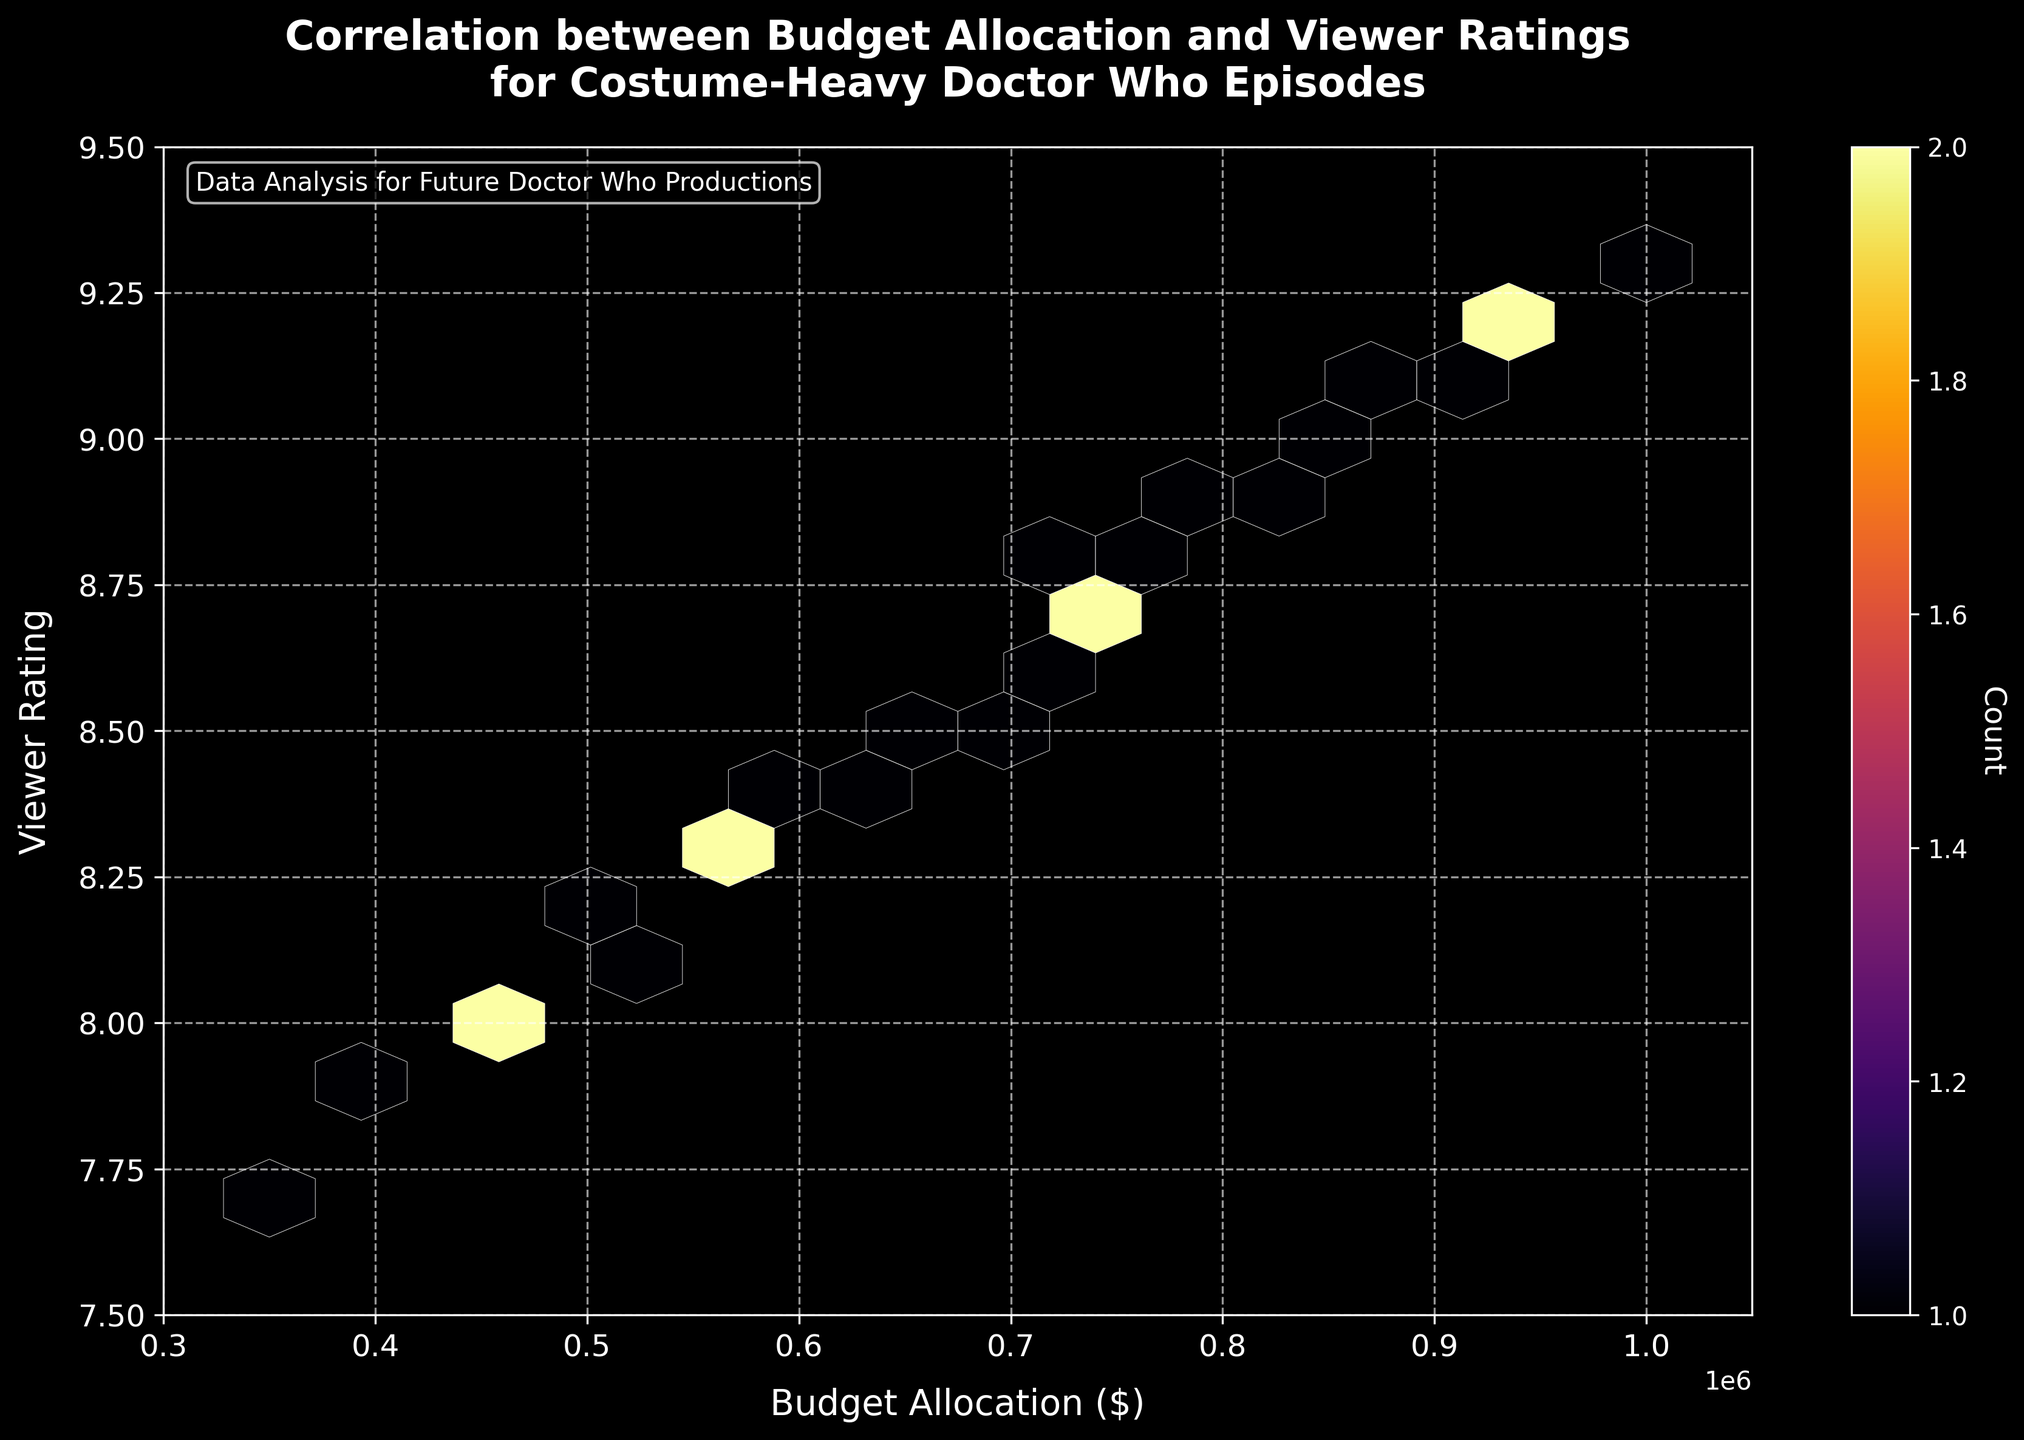How many bins are shown in the hexbin plot? The hexbin plot uses a grid of hexagons, and the number of bins corresponds to the number of hexagons shown. In this plot, the grid size is set to 15, which means there will be approximately 15 bins along each axis, resulting in a more granular hexbin plot.
Answer: Approximately 225 bins What's the title of the hexbin plot? The title is prominently displayed at the top of the plot. It reads: "Correlation between Budget Allocation and Viewer Ratings for Costume-Heavy Doctor Who Episodes."
Answer: Correlation between Budget Allocation and Viewer Ratings for Costume-Heavy Doctor Who Episodes What are the axis labels in the plot? The labels for the axes can be found near the x-axis and y-axis. The x-axis is labeled "Budget Allocation ($)," and the y-axis is labeled "Viewer Rating."
Answer: Budget Allocation ($) on x-axis and Viewer Rating on y-axis What is the range of budget allocations shown in the plot? Looking at the x-axis, the range of budget allocations spans from $300,000 to $1,050,000, as indicated by the limits set on the axis.
Answer: $300,000 to $1,050,000 What is the highest viewer rating in the dataset, and what budget allocation does it correspond to? The highest viewer rating can be found on the y-axis, peaking at approximately 9.3. The corresponding budget allocation for this highest rating, as per the data provided, is $1,000,000.
Answer: 9.3 with $1,000,000 budget How many data points fall in the bin with the highest count? The color intensity in the hexbin plot indicates the number of data points within each bin. The color bar on the right helps identify the bin with the highest count. This bin corresponds to the darkest color, which indicates a count of 2.
Answer: 2 data points Which budget allocation range has the densest concentration of viewer ratings based on the hexbin plot? By examining the hexbin plot, the densest concentration of viewer ratings is where the hexagons are most tightly clustered and exhibit darker colors. The range of budget allocation with the densest concentration falls between $700,000 and $800,000.
Answer: $700,000 to $800,000 Is there a visible correlation between budget allocation and viewer ratings based on the hexbin plot? The hexbin plot shows a trend where higher budget allocations seem to generally correspond to higher viewer ratings. This positive correlation can be observed as the hexagons shift upwards along the y-axis with increasing x-values.
Answer: Yes, positive correlation Do episodes with a budget allocation of $500,000 to $600,000 have viewer ratings above 8.2? Observing the regions within the $500,000 to $600,000 range on the x-axis, there are hexagons representing viewer ratings consistently above 8.2, indicating that episodes with these budgets indeed have ratings above 8.2.
Answer: Yes In what range does the majority of viewer ratings fall? The y-axis shows viewer ratings between 7.5 and 9.5, but the highest density of points (as indicated by the darkest hexagons) indicates that most viewer ratings cluster between 8.2 and 8.9.
Answer: 8.2 to 8.9 